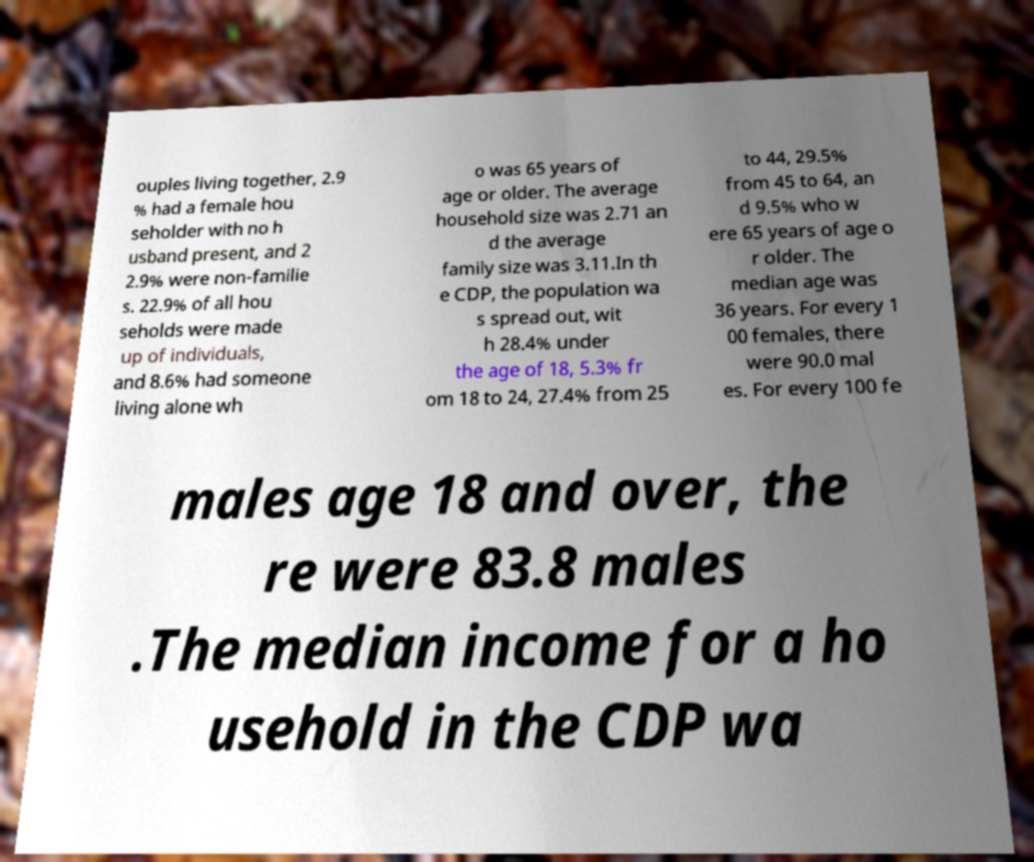Can you accurately transcribe the text from the provided image for me? ouples living together, 2.9 % had a female hou seholder with no h usband present, and 2 2.9% were non-familie s. 22.9% of all hou seholds were made up of individuals, and 8.6% had someone living alone wh o was 65 years of age or older. The average household size was 2.71 an d the average family size was 3.11.In th e CDP, the population wa s spread out, wit h 28.4% under the age of 18, 5.3% fr om 18 to 24, 27.4% from 25 to 44, 29.5% from 45 to 64, an d 9.5% who w ere 65 years of age o r older. The median age was 36 years. For every 1 00 females, there were 90.0 mal es. For every 100 fe males age 18 and over, the re were 83.8 males .The median income for a ho usehold in the CDP wa 